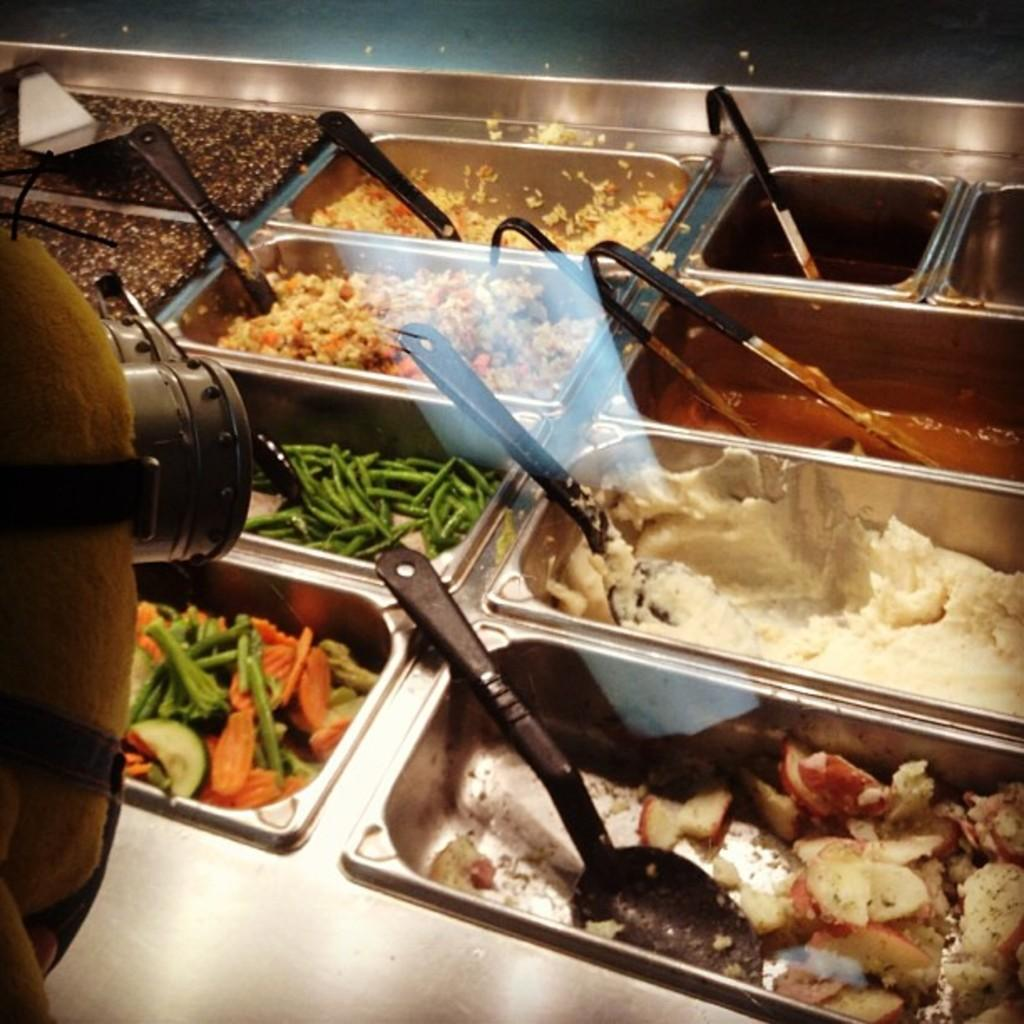What types of food items can be seen in the image? There are different food items in the image. How are the food items arranged in the image? The food items are kept in bowls. Where are the bowls with food items placed? The bowls are placed on a table. What type of store can be seen in the image? There is no store present in the image; it features different food items in bowls placed on a table. What is the condition of the sofa in the image? There is no sofa present in the image. 